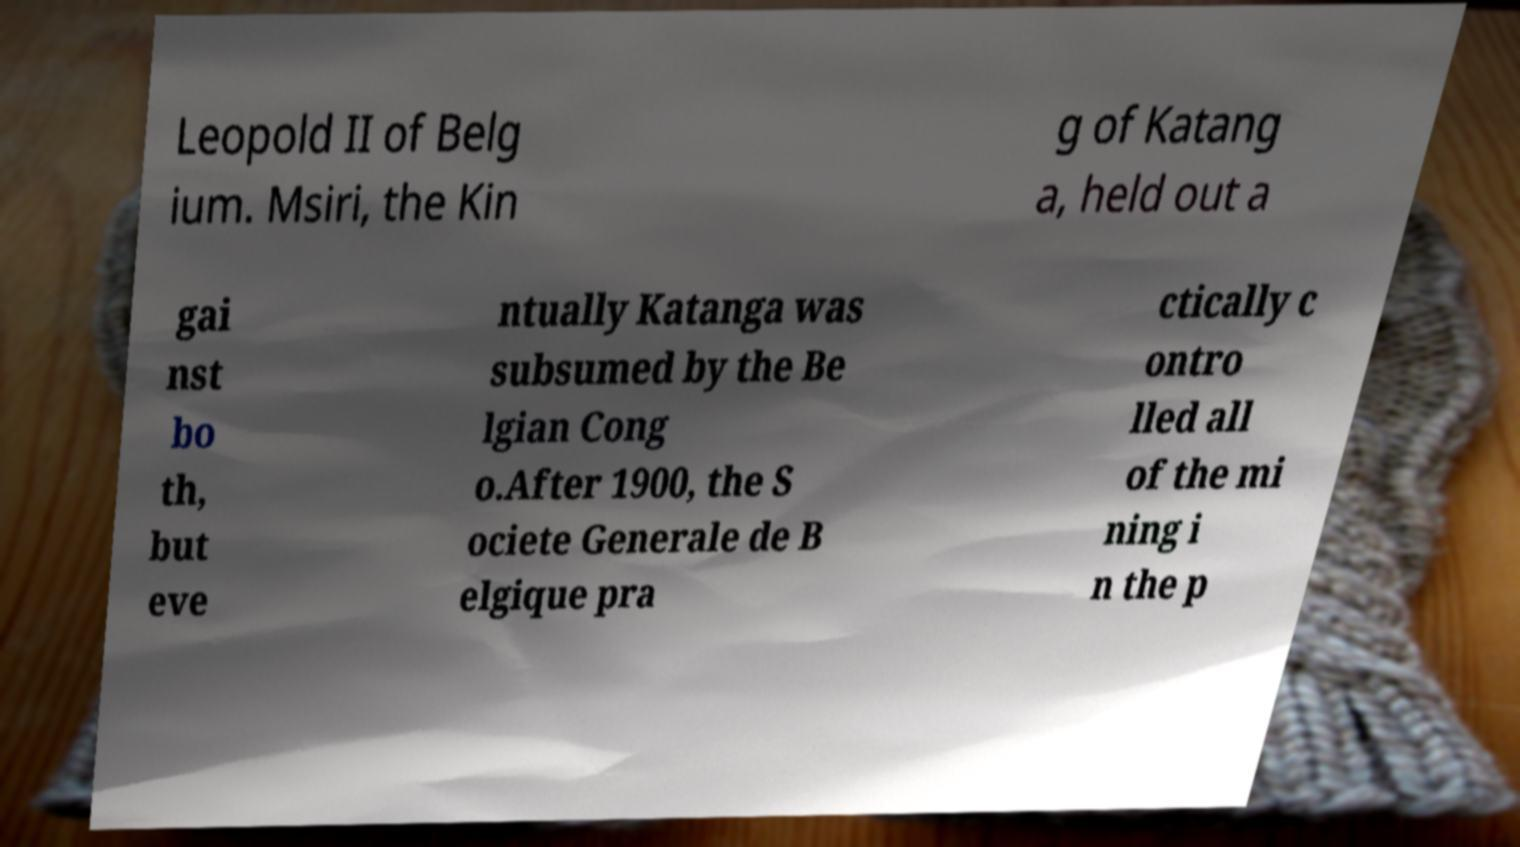Could you assist in decoding the text presented in this image and type it out clearly? Leopold II of Belg ium. Msiri, the Kin g of Katang a, held out a gai nst bo th, but eve ntually Katanga was subsumed by the Be lgian Cong o.After 1900, the S ociete Generale de B elgique pra ctically c ontro lled all of the mi ning i n the p 